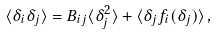<formula> <loc_0><loc_0><loc_500><loc_500>\langle \delta _ { i } \delta _ { j } \rangle = B _ { i j } \langle \delta _ { j } ^ { 2 } \rangle + \langle \delta _ { j } f _ { i } ( \delta _ { j } ) \rangle \, ,</formula> 